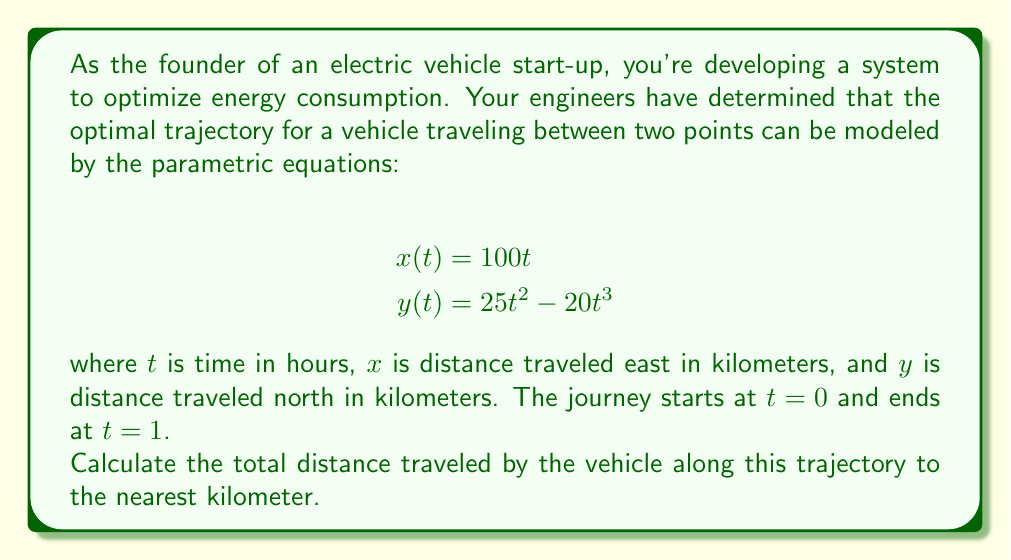Can you solve this math problem? To find the total distance traveled along a parametric curve, we need to use the arc length formula:

$$L = \int_a^b \sqrt{\left(\frac{dx}{dt}\right)^2 + \left(\frac{dy}{dt}\right)^2} dt$$

where $a$ and $b$ are the start and end values of $t$.

Step 1: Find $\frac{dx}{dt}$ and $\frac{dy}{dt}$
$$\frac{dx}{dt} = 100$$
$$\frac{dy}{dt} = 50t - 60t^2$$

Step 2: Substitute these into the arc length formula
$$L = \int_0^1 \sqrt{(100)^2 + (50t - 60t^2)^2} dt$$

Step 3: Simplify under the square root
$$L = \int_0^1 \sqrt{10000 + 2500t^2 - 6000t^3 + 3600t^4} dt$$

Step 4: This integral is too complex to solve analytically, so we need to use numerical integration. We can use a computer algebra system or numerical approximation method like Simpson's rule to evaluate this integral.

Using a numerical integration tool, we get:
$$L \approx 101.8243$$

Step 5: Round to the nearest kilometer
$$L \approx 102 \text{ km}$$
Answer: 102 km 